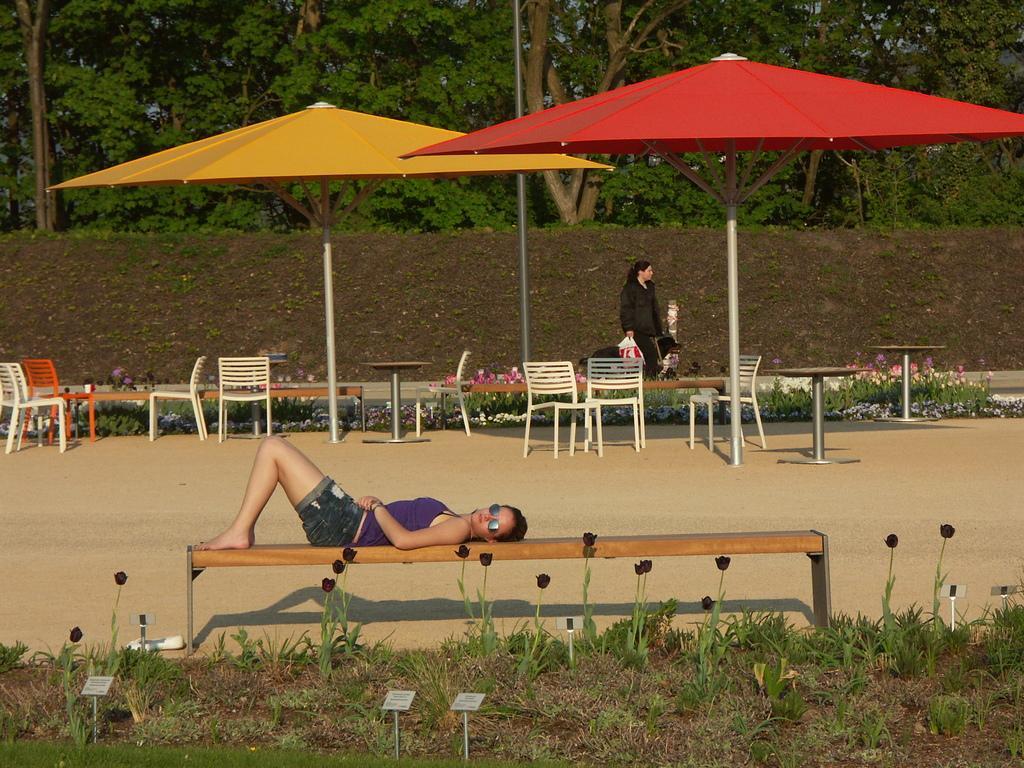How would you summarize this image in a sentence or two? This picture shows a woman laying on the bench and she wore sunglasses and we see another woman walking and she is holding a carry bag in her hand and we see a dog and we see couple of umbrellas and trees and few chairs and tables and plants with flowers. 